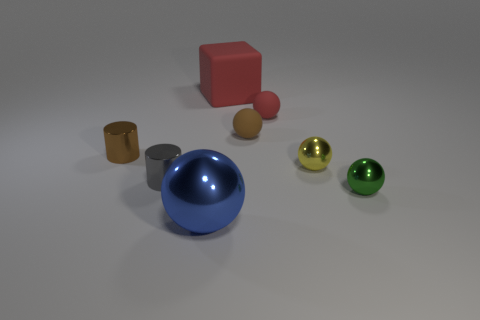How many big things are either gray rubber objects or brown rubber spheres? 0 